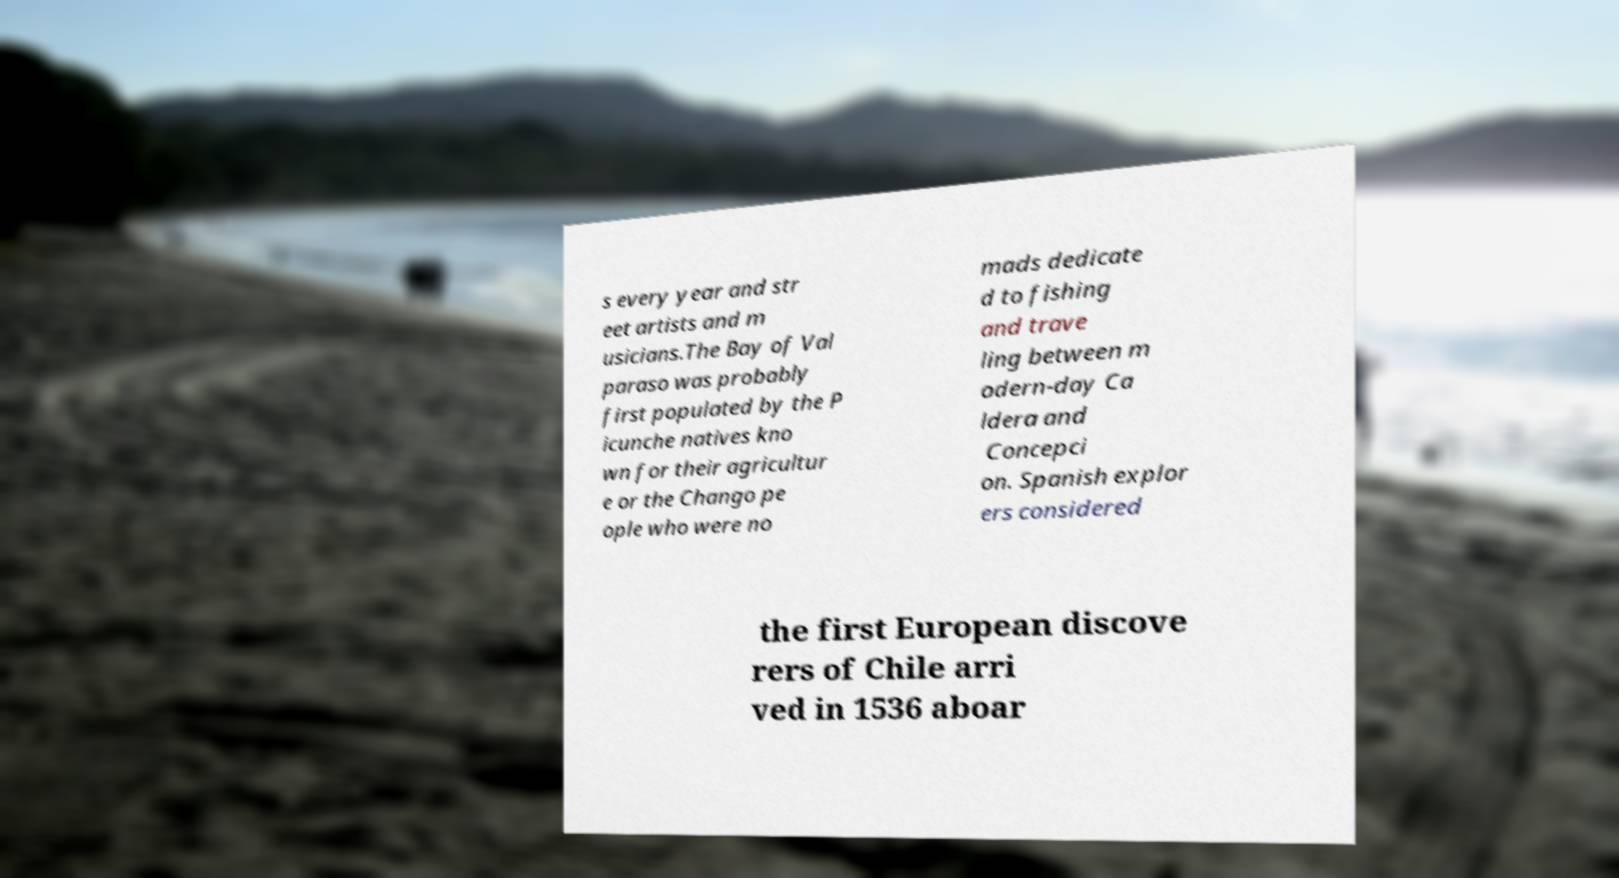Can you read and provide the text displayed in the image?This photo seems to have some interesting text. Can you extract and type it out for me? s every year and str eet artists and m usicians.The Bay of Val paraso was probably first populated by the P icunche natives kno wn for their agricultur e or the Chango pe ople who were no mads dedicate d to fishing and trave ling between m odern-day Ca ldera and Concepci on. Spanish explor ers considered the first European discove rers of Chile arri ved in 1536 aboar 